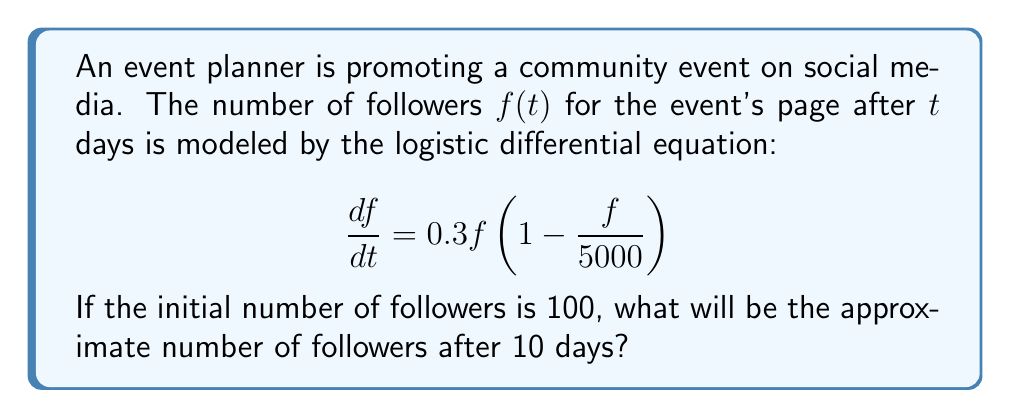Can you answer this question? To solve this problem, we need to use the solution to the logistic differential equation:

1) The general solution to the logistic equation $\frac{df}{dt} = rf(1 - \frac{f}{K})$ is:

   $$f(t) = \frac{K}{1 + (\frac{K}{f_0} - 1)e^{-rt}}$$

   Where $K$ is the carrying capacity, $r$ is the growth rate, and $f_0$ is the initial population.

2) In our case:
   $K = 5000$ (carrying capacity)
   $r = 0.3$ (growth rate)
   $f_0 = 100$ (initial followers)
   $t = 10$ (days)

3) Substituting these values into the solution:

   $$f(10) = \frac{5000}{1 + (\frac{5000}{100} - 1)e^{-0.3(10)}}$$

4) Simplify:
   $$f(10) = \frac{5000}{1 + 49e^{-3}}$$

5) Calculate:
   $$f(10) \approx 1018.3$$

6) Round to the nearest whole number:
   $$f(10) \approx 1018$$

Therefore, after 10 days, the event's page will have approximately 1018 followers.
Answer: 1018 followers 